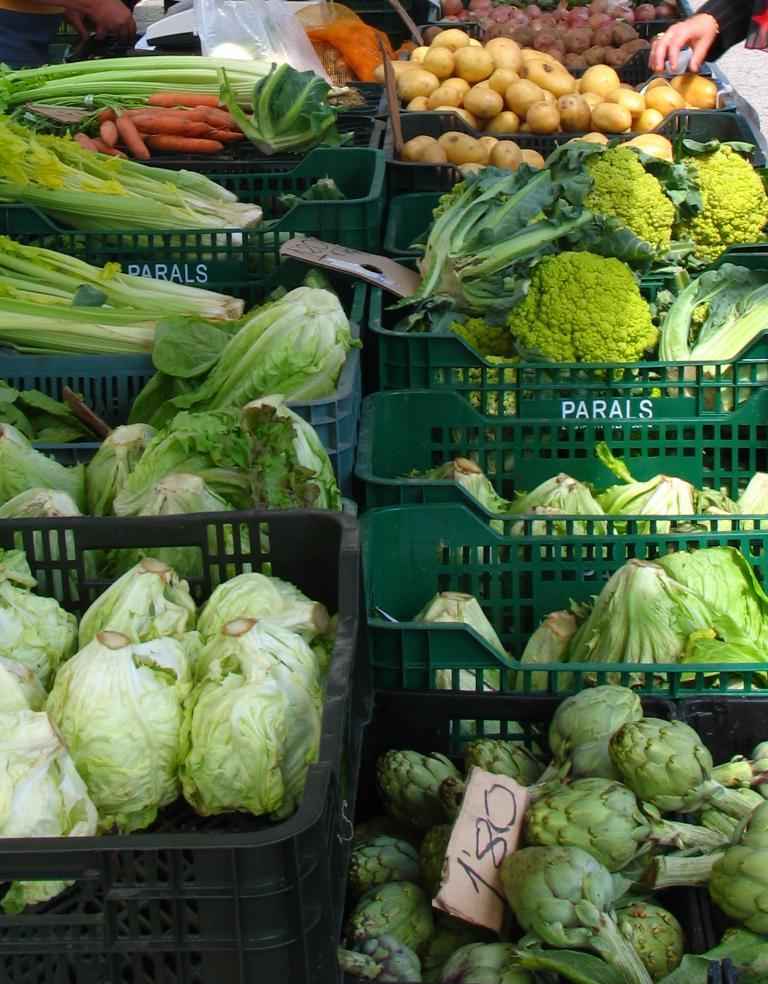What type of food can be seen in the image? There are vegetables in the image in the image. How are the vegetables arranged or organized? The vegetables are placed in baskets. Which specific vegetables can be identified in the image? Cabbage, broccoli, and carrots are visible in the image. What is the tax rate on the vegetables in the image? There is no information about tax rates in the image, as it only shows vegetables placed in baskets. 